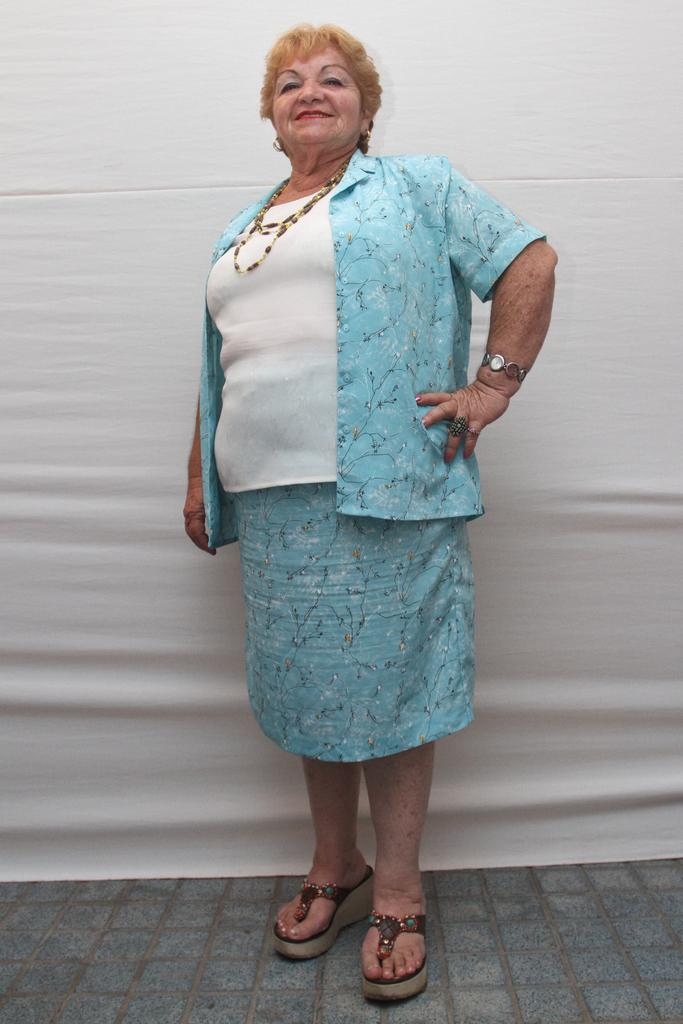What is the main subject of the image? There is a lady standing in the image. What can be seen beneath the lady's feet? The ground is visible in the image. What color is the background of the image? The background of the image is white. What type of arch can be seen in the background of the image? There is no arch present in the image; the background is white. 